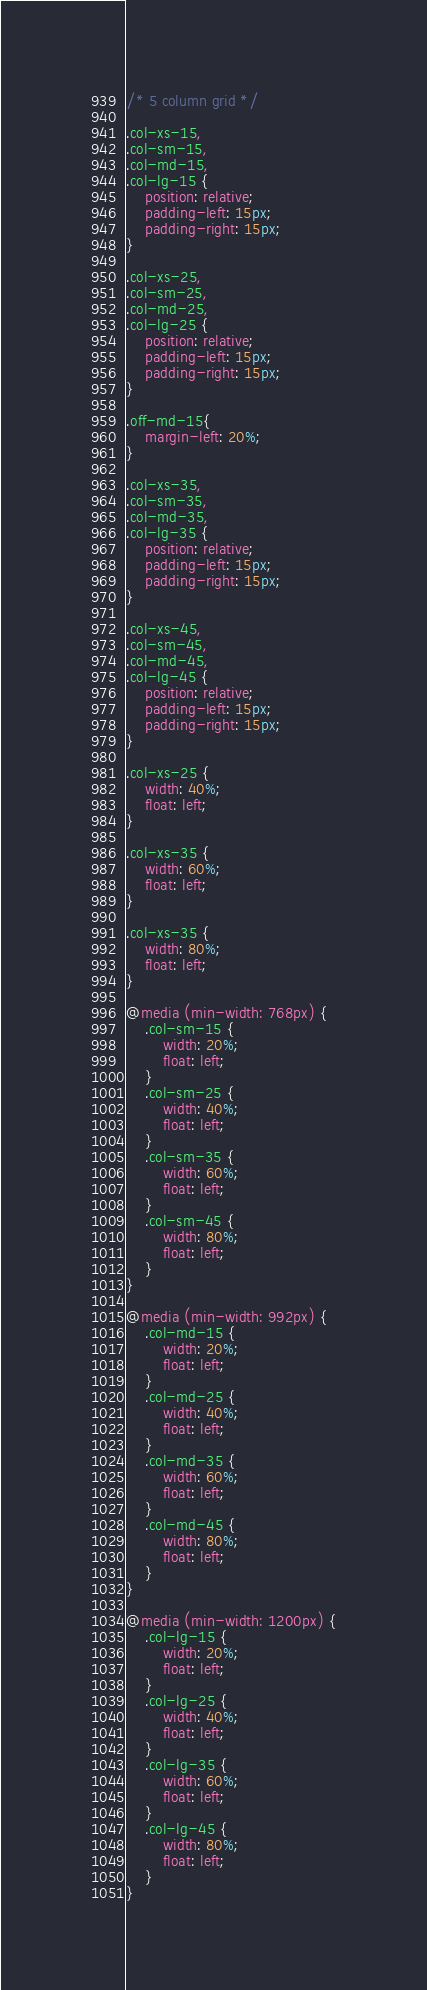Convert code to text. <code><loc_0><loc_0><loc_500><loc_500><_CSS_>/* 5 column grid */

.col-xs-15,
.col-sm-15,
.col-md-15,
.col-lg-15 {
    position: relative;
    padding-left: 15px;
    padding-right: 15px;
}

.col-xs-25,
.col-sm-25,
.col-md-25,
.col-lg-25 {
    position: relative;
    padding-left: 15px;
    padding-right: 15px;
}

.off-md-15{
	margin-left: 20%;
}

.col-xs-35,
.col-sm-35,
.col-md-35,
.col-lg-35 {
    position: relative;
    padding-left: 15px;
    padding-right: 15px;
}

.col-xs-45,
.col-sm-45,
.col-md-45,
.col-lg-45 {
    position: relative;
    padding-left: 15px;
    padding-right: 15px;
}

.col-xs-25 {
    width: 40%;
    float: left;
}

.col-xs-35 {
    width: 60%;
    float: left;
}

.col-xs-35 {
    width: 80%;
    float: left;
}

@media (min-width: 768px) {
	.col-sm-15 {
        width: 20%;
        float: left;
    }
    .col-sm-25 {
        width: 40%;
        float: left;
    }
    .col-sm-35 {
        width: 60%;
        float: left;
    }
    .col-sm-45 {
        width: 80%;
        float: left;
    }
}

@media (min-width: 992px) {
    .col-md-15 {
        width: 20%;
        float: left;
    }
    .col-md-25 {
        width: 40%;
        float: left;
    }
    .col-md-35 {
        width: 60%;
        float: left;
    }
    .col-md-45 {
        width: 80%;
        float: left;
    }
}

@media (min-width: 1200px) {
    .col-lg-15 {
        width: 20%;
        float: left;
    }
    .col-lg-25 {
        width: 40%;
        float: left;
    }
    .col-lg-35 {
        width: 60%;
        float: left;
    }
    .col-lg-45 {
        width: 80%;
        float: left;
    }
}</code> 